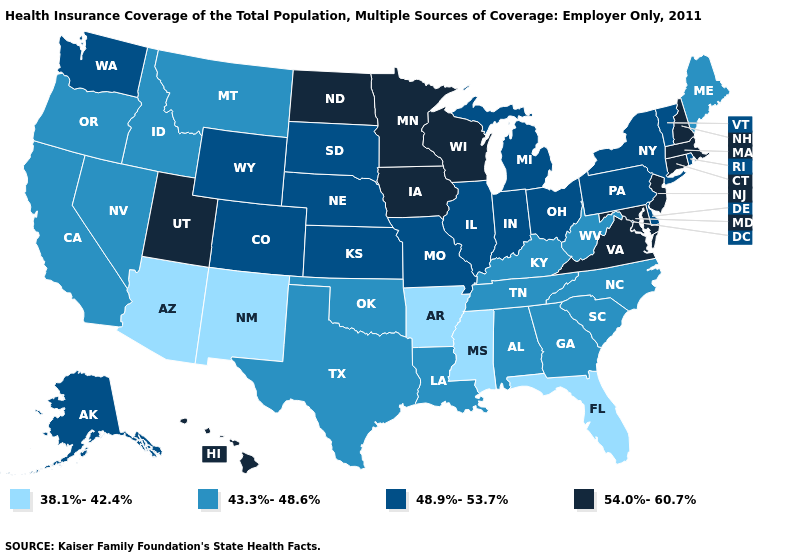What is the highest value in the MidWest ?
Quick response, please. 54.0%-60.7%. What is the lowest value in the USA?
Give a very brief answer. 38.1%-42.4%. Which states have the lowest value in the USA?
Be succinct. Arizona, Arkansas, Florida, Mississippi, New Mexico. Name the states that have a value in the range 48.9%-53.7%?
Short answer required. Alaska, Colorado, Delaware, Illinois, Indiana, Kansas, Michigan, Missouri, Nebraska, New York, Ohio, Pennsylvania, Rhode Island, South Dakota, Vermont, Washington, Wyoming. Name the states that have a value in the range 38.1%-42.4%?
Be succinct. Arizona, Arkansas, Florida, Mississippi, New Mexico. Among the states that border Tennessee , which have the highest value?
Be succinct. Virginia. Does Massachusetts have the same value as Wisconsin?
Answer briefly. Yes. What is the value of California?
Answer briefly. 43.3%-48.6%. Does Michigan have the highest value in the MidWest?
Give a very brief answer. No. How many symbols are there in the legend?
Be succinct. 4. What is the lowest value in the USA?
Write a very short answer. 38.1%-42.4%. Is the legend a continuous bar?
Short answer required. No. Name the states that have a value in the range 43.3%-48.6%?
Write a very short answer. Alabama, California, Georgia, Idaho, Kentucky, Louisiana, Maine, Montana, Nevada, North Carolina, Oklahoma, Oregon, South Carolina, Tennessee, Texas, West Virginia. Among the states that border Minnesota , does South Dakota have the highest value?
Give a very brief answer. No. Does the map have missing data?
Concise answer only. No. 